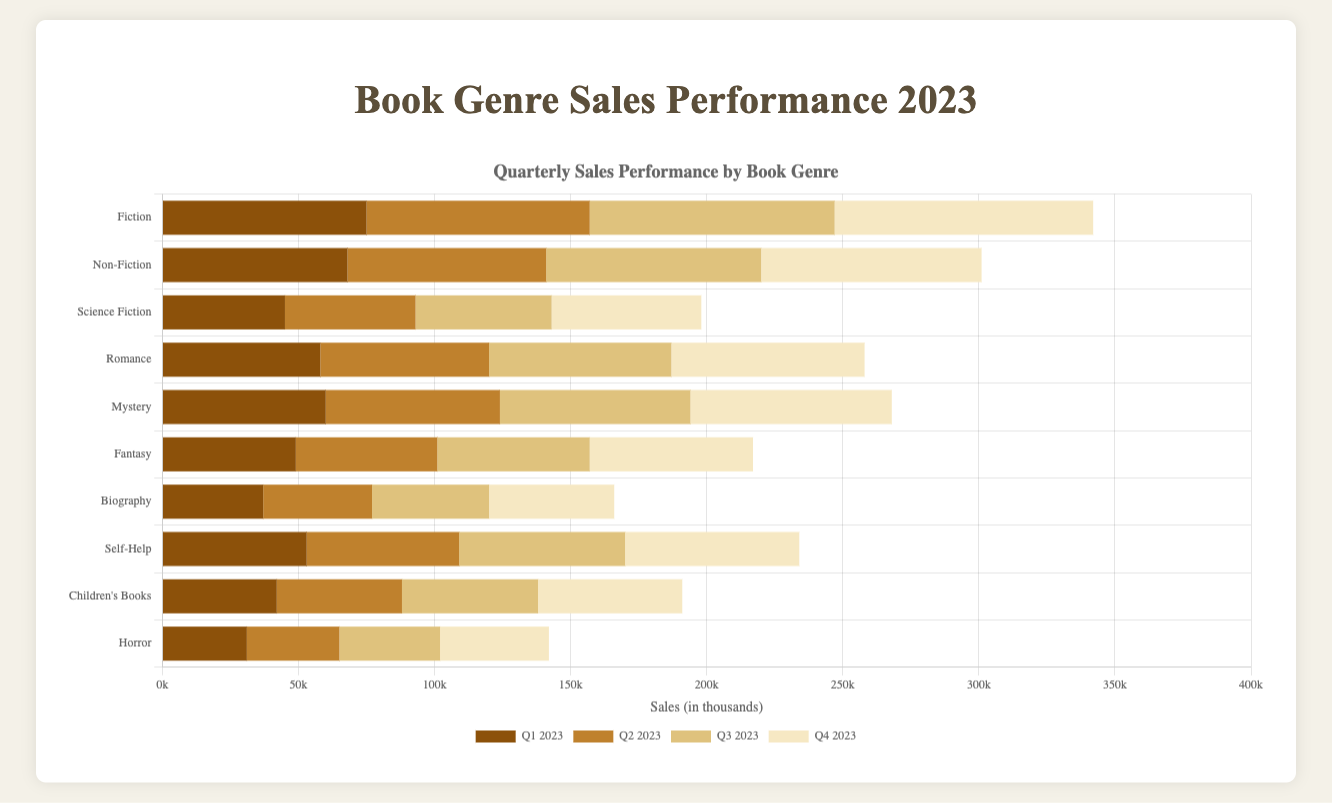What's the total sales for Fiction across all quarters in 2023? Sum the sales of Fiction for each quarter: 75000 (Q1) + 82000 (Q2) + 90000 (Q3) + 95000 (Q4) = 342000.
Answer: 342000 Which genre had the highest sales in Q4 2023? Compare the Q4 sales of each genre: Fiction (95000), Non-Fiction (81000), Science Fiction (55000), Romance (71000), Mystery (74000), Fantasy (60000), Biography (46000), Self-Help (64000), Children's Books (53000), Horror (40000). Fiction had the highest sales.
Answer: Fiction Is the sales performance of Science Fiction higher in Q2 2023 or Q3 2023? Compare the sales of Science Fiction in Q2 (48000) and Q3 (50000). Q3 has higher sales.
Answer: Q3 2023 How does the Q1 2023 sales of Children’s Books compare to the Q1 2023 sales of Biography? Compare the Q1 sales: Children's Books (42000) vs Biography (37000). Children's Books has higher sales.
Answer: Children’s Books By how much did the sales of Romance increase from Q1 to Q4 2023? Subtract Q1 sales (58000) from Q4 sales (71000): 71000 - 58000 = 13000.
Answer: 13000 What's the average quarterly sales for Fantasy in 2023? Sum the quarterly sales of Fantasy and divide by 4: (49000 + 52000 + 56000 + 60000) / 4 = 217000 / 4 = 54250.
Answer: 54250 Which genre saw the smallest increase in sales from Q1 to Q4 2023? Calculate the increase for each genre: Fiction (95000-75000=20000), Non-Fiction (81000-68000=13000), Science Fiction (55000-45000=10000), Romance (71000-58000=13000), Mystery (74000-60000=14000), Fantasy (60000-49000=11000), Biography (46000-37000=9000), Self-Help (64000-53000=11000), Children's Books (53000-42000=11000), Horror (40000-31000=9000). Biography and Horror saw the smallest increase (9000).
Answer: Biography and Horror Calculate the sum of Q3 2023 sales for Self-Help and Children’s Books. Sum the Q3 sales of Self-Help (61000) and Children’s Books (50000): 61000 + 50000 = 111000.
Answer: 111000 Which genre has the second highest sales in Q2 2023? Rank the Q2 sales to find the second highest: Fiction (82000), Non-Fiction (73000), Science Fiction (48000), Romance (62000), Mystery (64000), Fantasy (52000), Biography (40000), Self-Help (56000), Children's Books (46000), Horror (34000). Non-Fiction is the second highest.
Answer: Non-Fiction Did Mystery genre sales in Q3 2023 exceed 70000? Check the Q3 sales of Mystery: 70000. It equals but does not exceed 70000.
Answer: No 